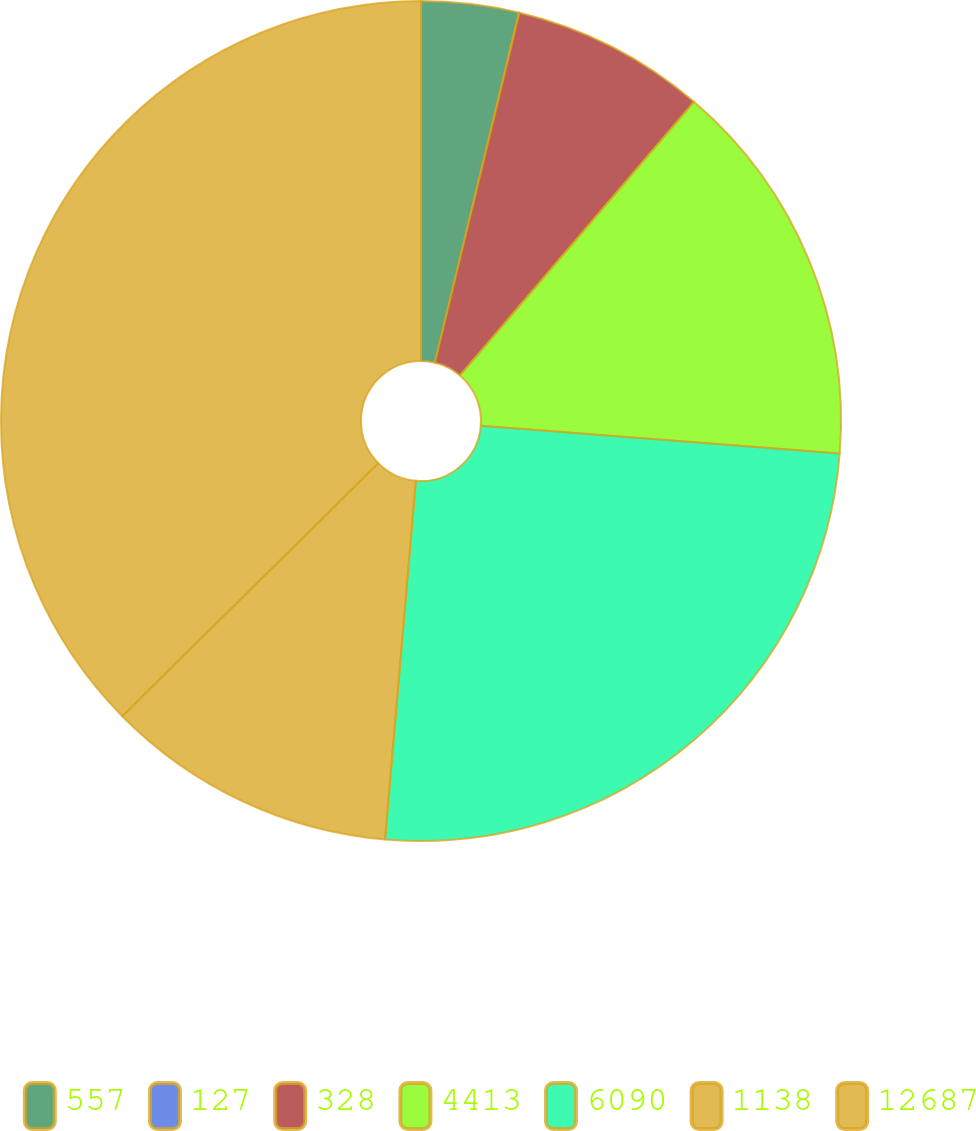Convert chart. <chart><loc_0><loc_0><loc_500><loc_500><pie_chart><fcel>557<fcel>127<fcel>328<fcel>4413<fcel>6090<fcel>1138<fcel>12687<nl><fcel>3.75%<fcel>0.02%<fcel>7.49%<fcel>14.97%<fcel>25.13%<fcel>11.23%<fcel>37.4%<nl></chart> 